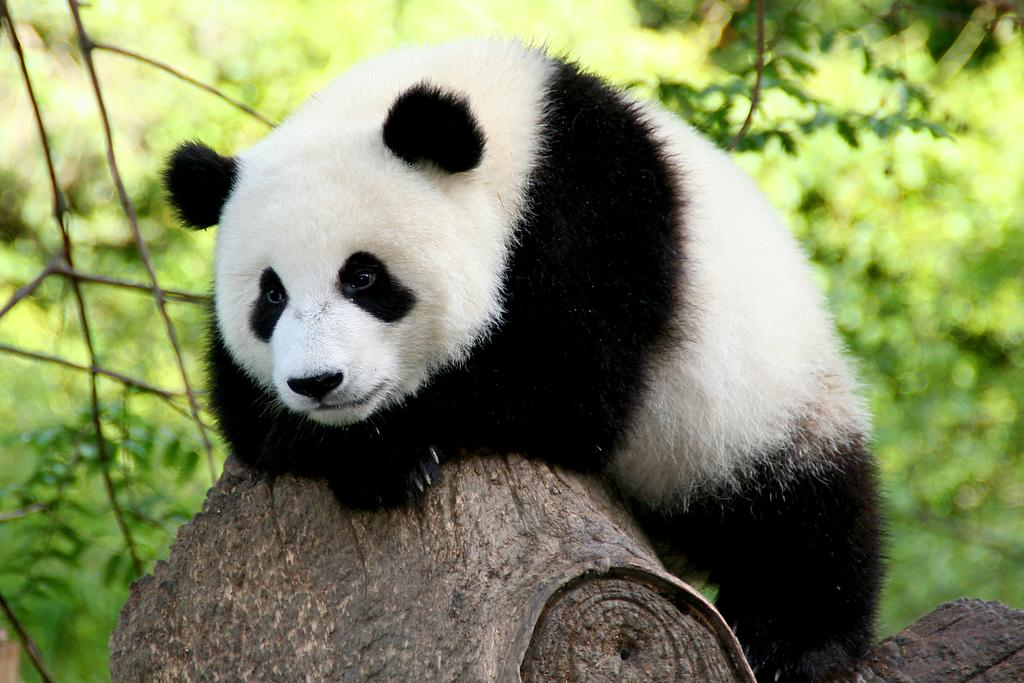What animal is the main subject of the image? There is a panda in the image. What is the panda standing on? The panda is on a trunk in the image. Which direction is the panda looking? The panda is looking to the left side in the image. What can be seen in the background of the image? There are plants in the background of the image. What type of fuel is the panda using to power its movements in the image? The panda is not using any fuel to power its movements in the image; it is a stationary animal. Can you see a fork in the image? There is no fork present in the image. 